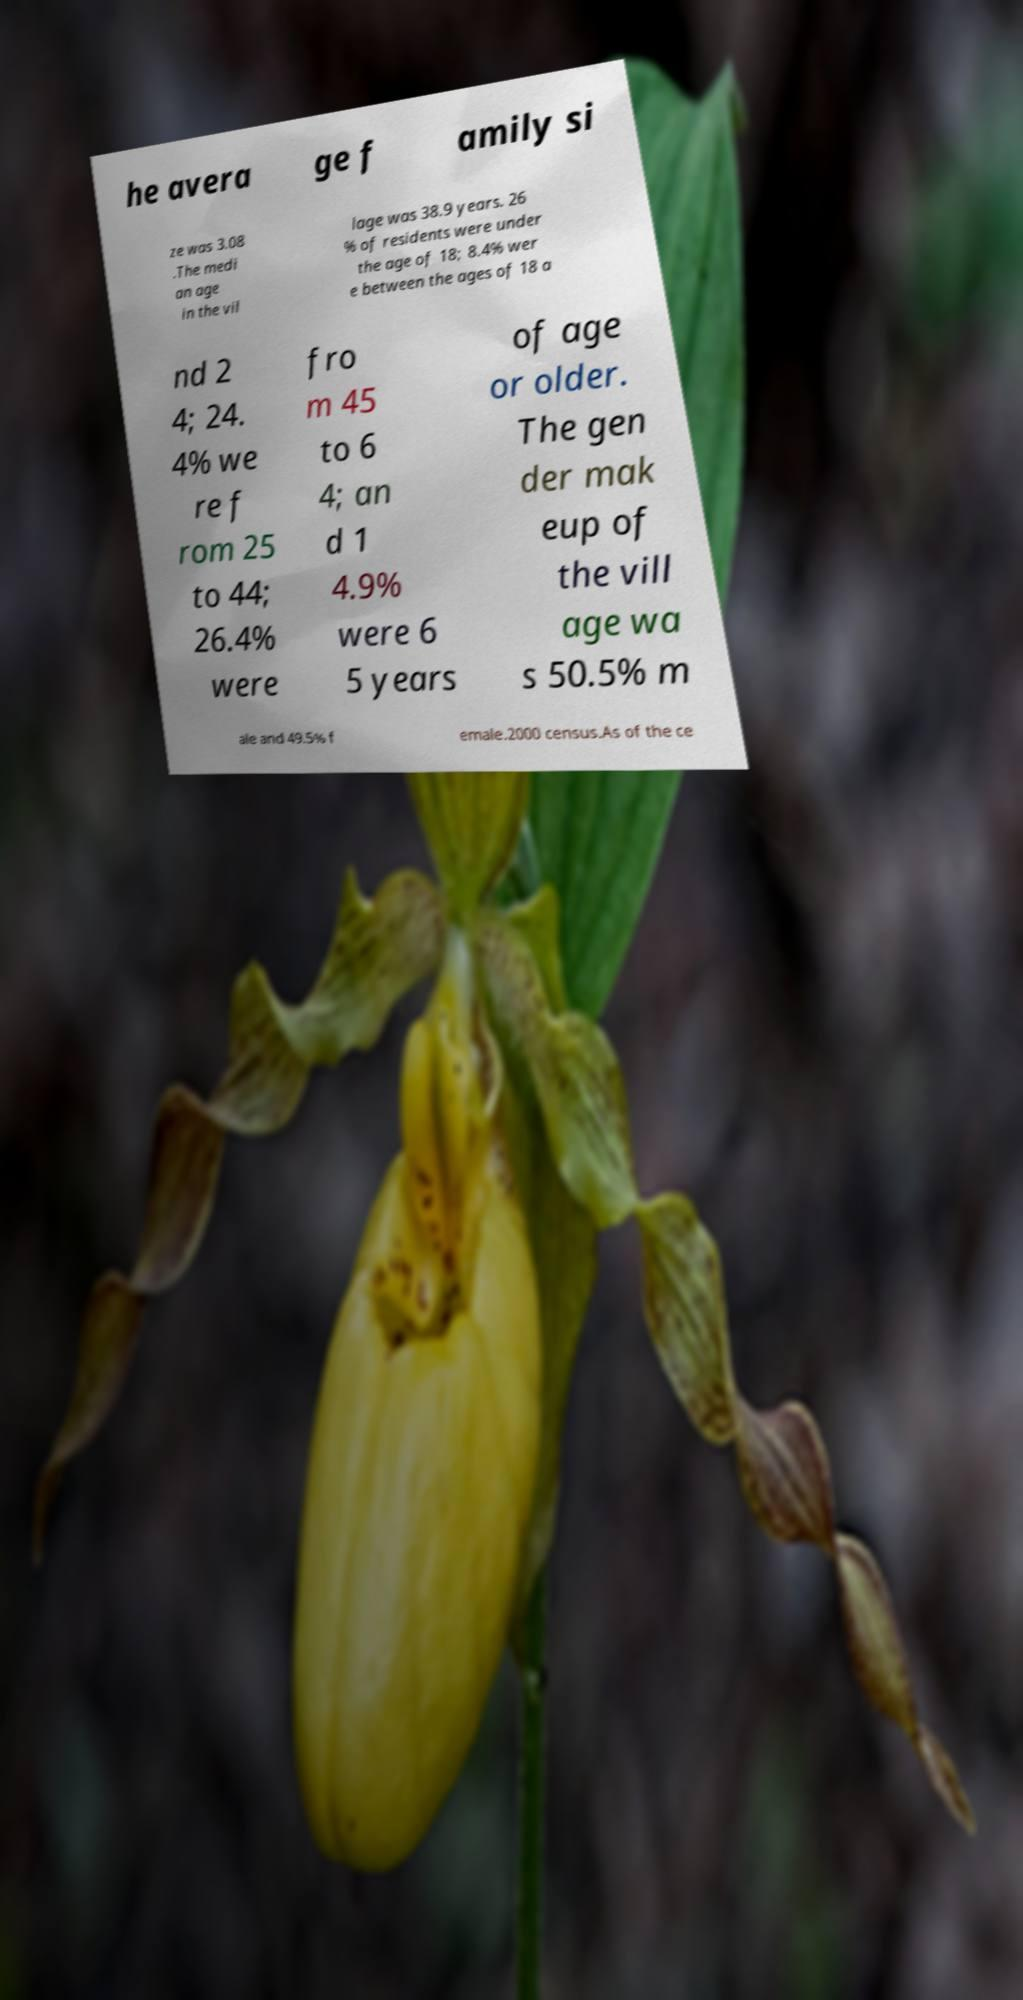Please identify and transcribe the text found in this image. he avera ge f amily si ze was 3.08 .The medi an age in the vil lage was 38.9 years. 26 % of residents were under the age of 18; 8.4% wer e between the ages of 18 a nd 2 4; 24. 4% we re f rom 25 to 44; 26.4% were fro m 45 to 6 4; an d 1 4.9% were 6 5 years of age or older. The gen der mak eup of the vill age wa s 50.5% m ale and 49.5% f emale.2000 census.As of the ce 